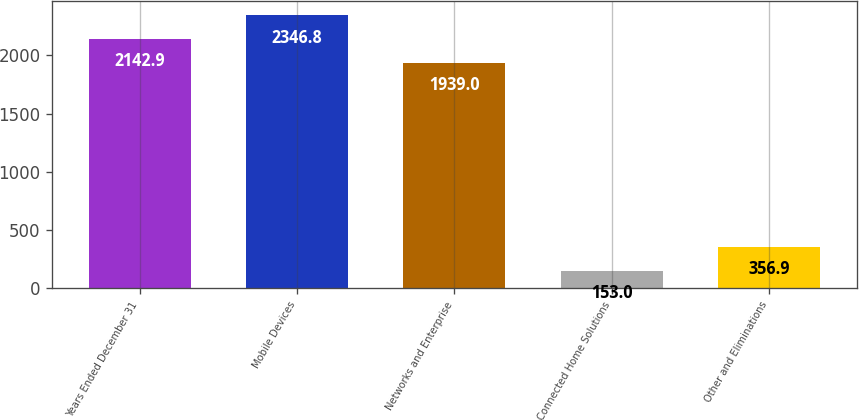Convert chart. <chart><loc_0><loc_0><loc_500><loc_500><bar_chart><fcel>Years Ended December 31<fcel>Mobile Devices<fcel>Networks and Enterprise<fcel>Connected Home Solutions<fcel>Other and Eliminations<nl><fcel>2142.9<fcel>2346.8<fcel>1939<fcel>153<fcel>356.9<nl></chart> 